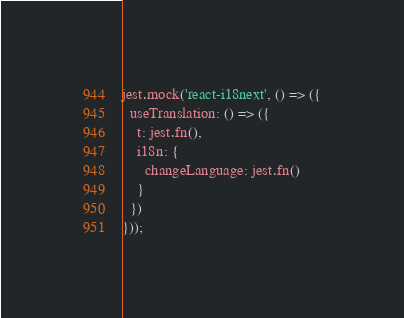Convert code to text. <code><loc_0><loc_0><loc_500><loc_500><_JavaScript_>
jest.mock('react-i18next', () => ({
  useTranslation: () => ({
    t: jest.fn(),
    i18n: {
      changeLanguage: jest.fn()
    }
  })
}));
</code> 